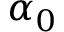<formula> <loc_0><loc_0><loc_500><loc_500>\alpha _ { 0 }</formula> 